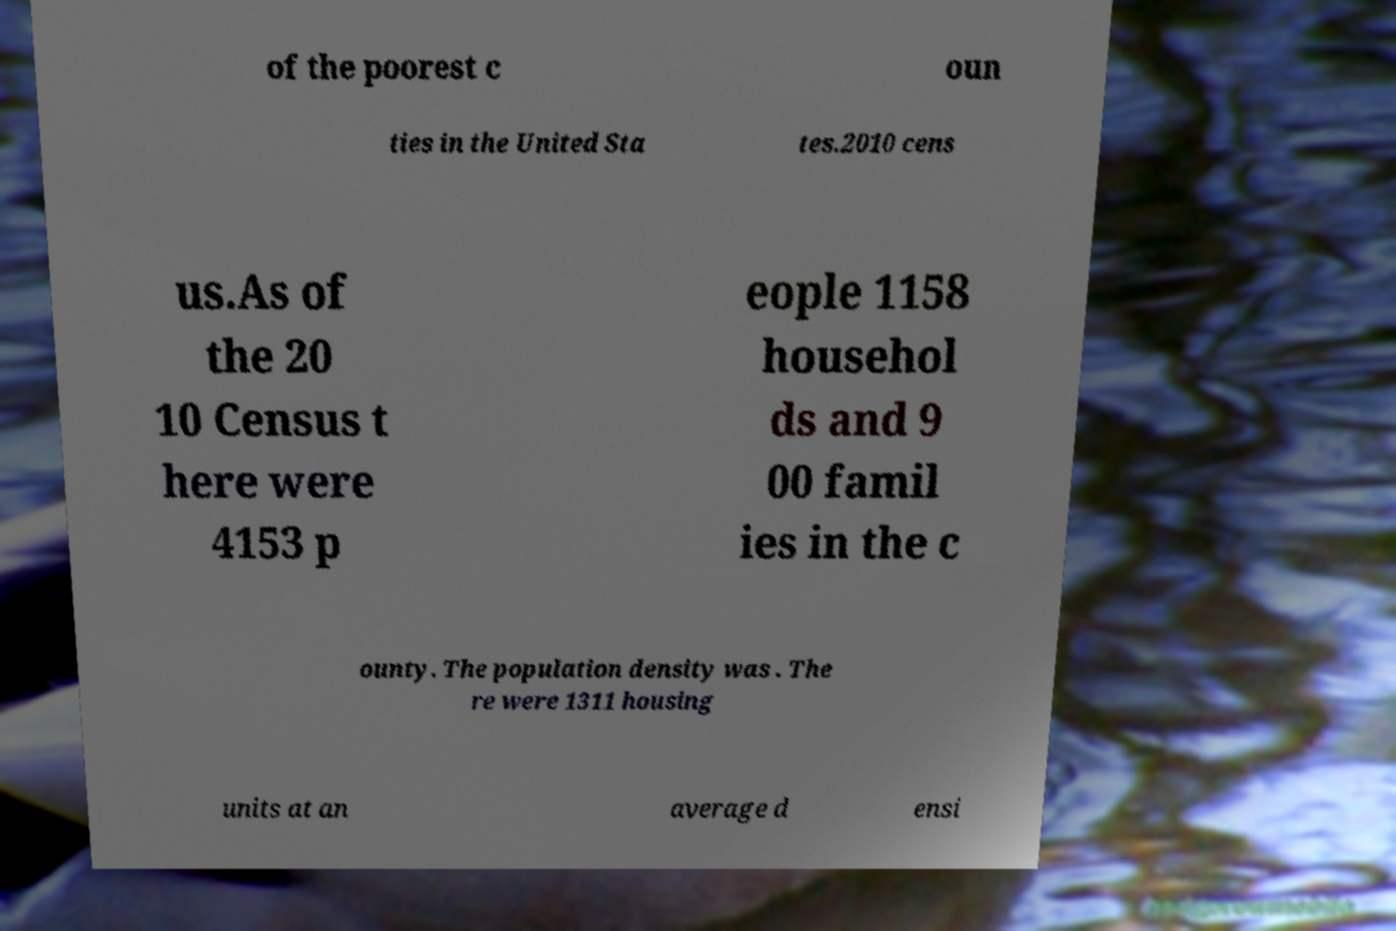For documentation purposes, I need the text within this image transcribed. Could you provide that? of the poorest c oun ties in the United Sta tes.2010 cens us.As of the 20 10 Census t here were 4153 p eople 1158 househol ds and 9 00 famil ies in the c ounty. The population density was . The re were 1311 housing units at an average d ensi 